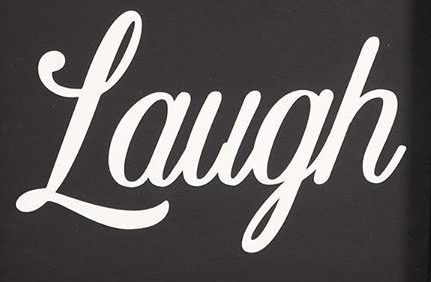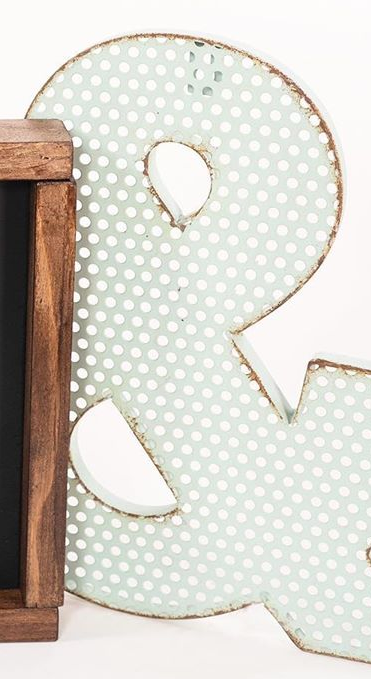What text appears in these images from left to right, separated by a semicolon? Laugh; & 